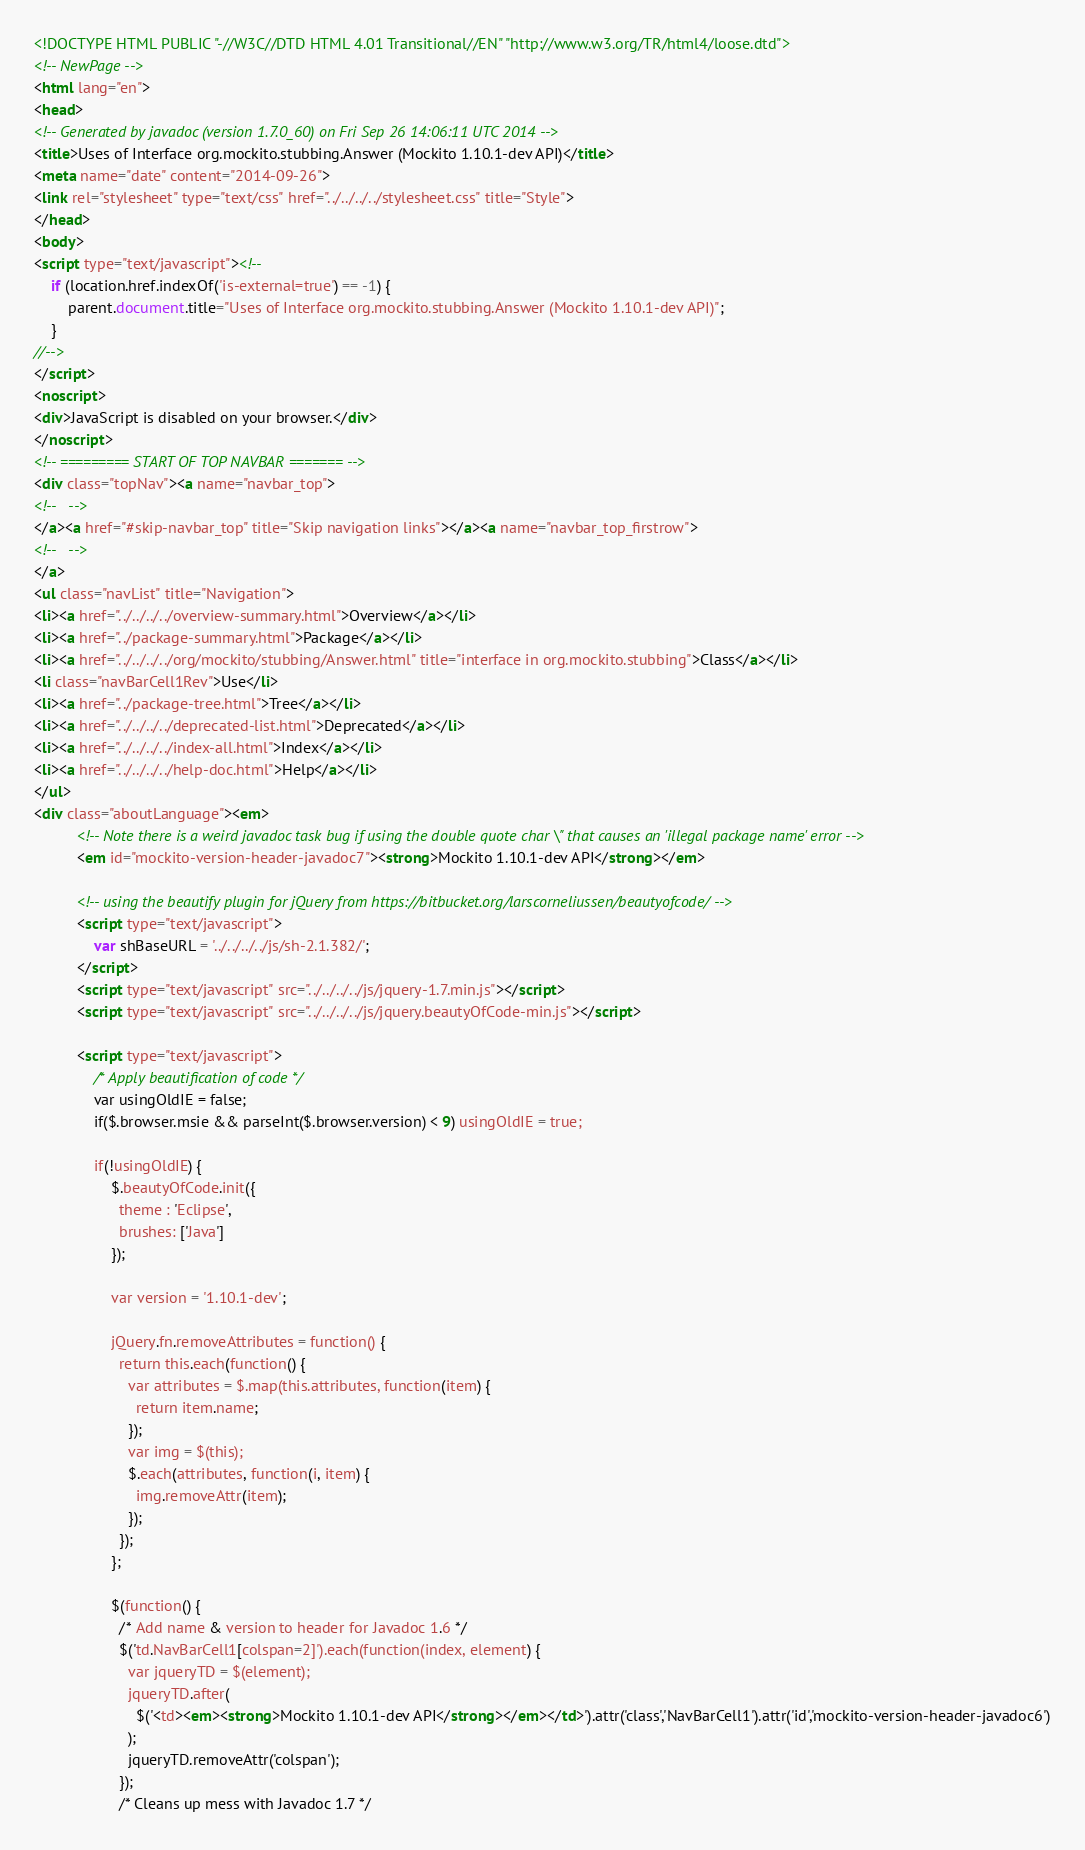<code> <loc_0><loc_0><loc_500><loc_500><_HTML_><!DOCTYPE HTML PUBLIC "-//W3C//DTD HTML 4.01 Transitional//EN" "http://www.w3.org/TR/html4/loose.dtd">
<!-- NewPage -->
<html lang="en">
<head>
<!-- Generated by javadoc (version 1.7.0_60) on Fri Sep 26 14:06:11 UTC 2014 -->
<title>Uses of Interface org.mockito.stubbing.Answer (Mockito 1.10.1-dev API)</title>
<meta name="date" content="2014-09-26">
<link rel="stylesheet" type="text/css" href="../../../../stylesheet.css" title="Style">
</head>
<body>
<script type="text/javascript"><!--
    if (location.href.indexOf('is-external=true') == -1) {
        parent.document.title="Uses of Interface org.mockito.stubbing.Answer (Mockito 1.10.1-dev API)";
    }
//-->
</script>
<noscript>
<div>JavaScript is disabled on your browser.</div>
</noscript>
<!-- ========= START OF TOP NAVBAR ======= -->
<div class="topNav"><a name="navbar_top">
<!--   -->
</a><a href="#skip-navbar_top" title="Skip navigation links"></a><a name="navbar_top_firstrow">
<!--   -->
</a>
<ul class="navList" title="Navigation">
<li><a href="../../../../overview-summary.html">Overview</a></li>
<li><a href="../package-summary.html">Package</a></li>
<li><a href="../../../../org/mockito/stubbing/Answer.html" title="interface in org.mockito.stubbing">Class</a></li>
<li class="navBarCell1Rev">Use</li>
<li><a href="../package-tree.html">Tree</a></li>
<li><a href="../../../../deprecated-list.html">Deprecated</a></li>
<li><a href="../../../../index-all.html">Index</a></li>
<li><a href="../../../../help-doc.html">Help</a></li>
</ul>
<div class="aboutLanguage"><em>
          <!-- Note there is a weird javadoc task bug if using the double quote char \" that causes an 'illegal package name' error -->
          <em id="mockito-version-header-javadoc7"><strong>Mockito 1.10.1-dev API</strong></em>

          <!-- using the beautify plugin for jQuery from https://bitbucket.org/larscorneliussen/beautyofcode/ -->
          <script type="text/javascript">
              var shBaseURL = '../../../../js/sh-2.1.382/';
          </script>
          <script type="text/javascript" src="../../../../js/jquery-1.7.min.js"></script>
          <script type="text/javascript" src="../../../../js/jquery.beautyOfCode-min.js"></script>

          <script type="text/javascript">
              /* Apply beautification of code */
              var usingOldIE = false;
              if($.browser.msie && parseInt($.browser.version) < 9) usingOldIE = true;

              if(!usingOldIE) {
                  $.beautyOfCode.init({
                    theme : 'Eclipse',
                    brushes: ['Java']
                  });

                  var version = '1.10.1-dev';

                  jQuery.fn.removeAttributes = function() {
                    return this.each(function() {
                      var attributes = $.map(this.attributes, function(item) {
                        return item.name;
                      });
                      var img = $(this);
                      $.each(attributes, function(i, item) {
                        img.removeAttr(item);
                      });
                    });
                  };

                  $(function() {
                    /* Add name & version to header for Javadoc 1.6 */
                    $('td.NavBarCell1[colspan=2]').each(function(index, element) {
                      var jqueryTD = $(element);
                      jqueryTD.after(
                        $('<td><em><strong>Mockito 1.10.1-dev API</strong></em></td>').attr('class','NavBarCell1').attr('id','mockito-version-header-javadoc6')
                      );
                      jqueryTD.removeAttr('colspan');
                    });
                    /* Cleans up mess with Javadoc 1.7 */</code> 